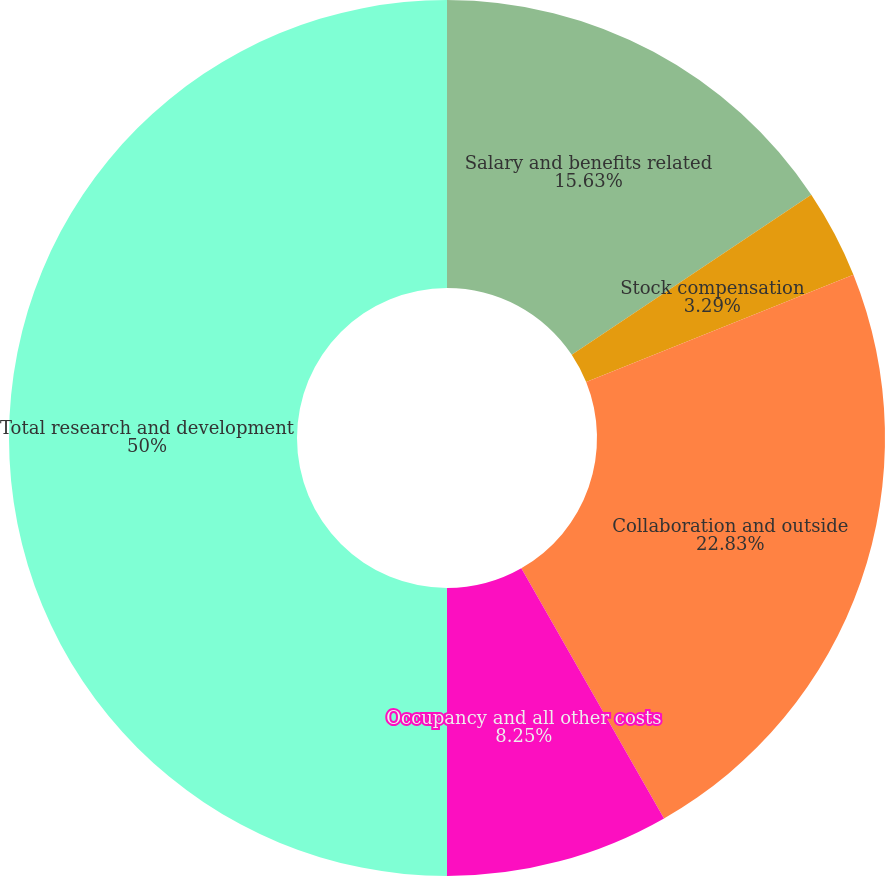Convert chart to OTSL. <chart><loc_0><loc_0><loc_500><loc_500><pie_chart><fcel>Salary and benefits related<fcel>Stock compensation<fcel>Collaboration and outside<fcel>Occupancy and all other costs<fcel>Total research and development<nl><fcel>15.63%<fcel>3.29%<fcel>22.83%<fcel>8.25%<fcel>50.0%<nl></chart> 